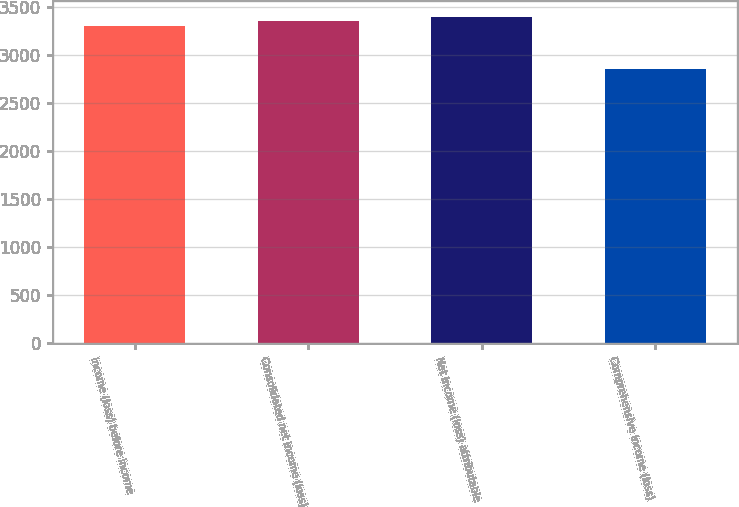Convert chart. <chart><loc_0><loc_0><loc_500><loc_500><bar_chart><fcel>Income (loss) before income<fcel>Consolidated net income (loss)<fcel>Net income (loss) attributable<fcel>Comprehensive income (loss)<nl><fcel>3305.8<fcel>3351.38<fcel>3396.96<fcel>2850<nl></chart> 